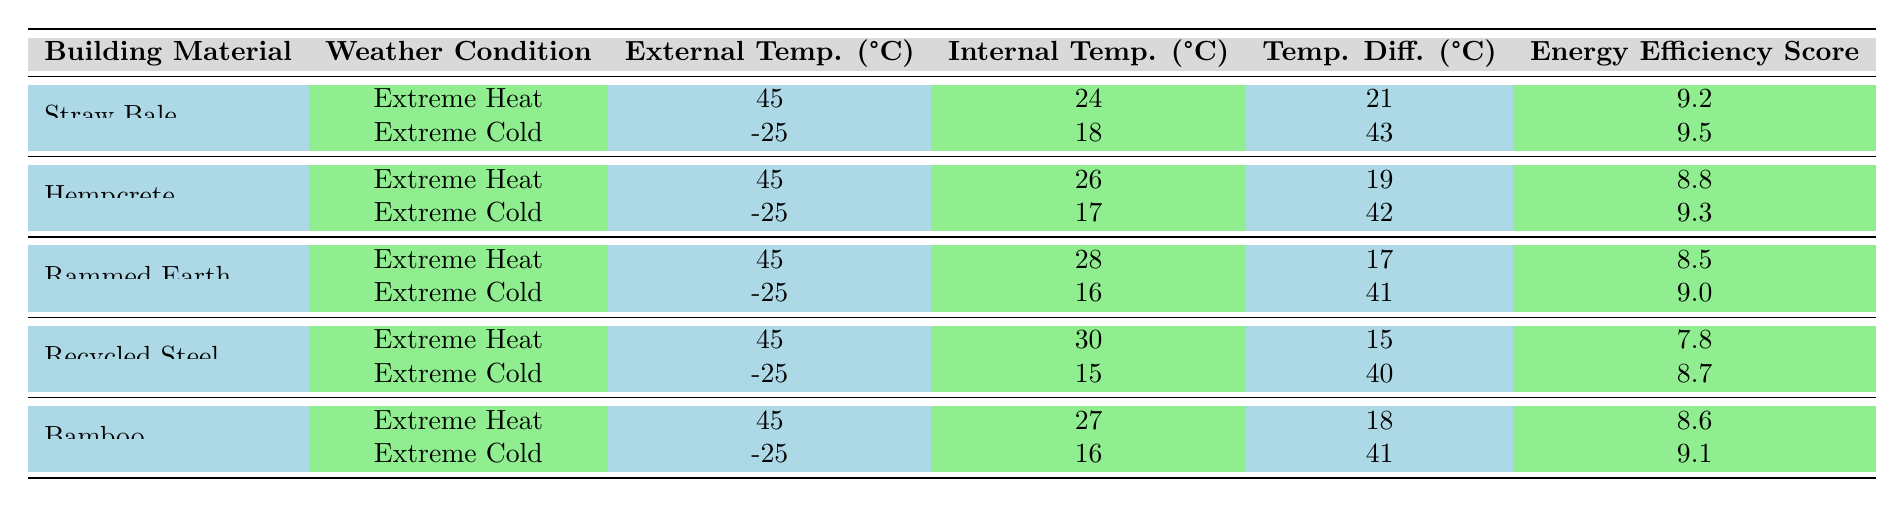What is the Energy Efficiency Score for Straw Bale in Extreme Heat? The table lists the Energy Efficiency Score for Straw Bale under Extreme Heat as 9.2.
Answer: 9.2 What is the Temperature Difference for Hempcrete in Extreme Cold? According to the table, the Temperature Difference for Hempcrete in Extreme Cold is 42°C.
Answer: 42 Which building material has the highest Energy Efficiency Score during Extreme Cold? In the table, Straw Bale has the highest Energy Efficiency Score of 9.5 in Extreme Cold.
Answer: Straw Bale What is the average Temperature Difference for Bamboo in both weather conditions? To calculate the average, add the Temperature Differences for Bamboo: (41 + 18) = 59, then divide by 2: 59 / 2 = 29.5.
Answer: 29.5 Is the Internal Temperature for Recycled Steel higher in Extreme Heat or Extreme Cold? The Internal Temperature for Recycled Steel in Extreme Heat is 30°C, while in Extreme Cold it is 15°C; therefore, it is higher in Extreme Heat.
Answer: Yes Which material maintains the highest Internal Temperature in Extreme Heat? The table shows that Recycled Steel maintains the highest Internal Temperature of 30°C in Extreme Heat.
Answer: Recycled Steel What is the total Temperature Difference for Hempcrete across both weather conditions? The total Temperature Difference for Hempcrete is (19 + 42) = 61°C.
Answer: 61 Is the Energy Efficiency Score for Rammed Earth lower in Extreme Heat compared to Bamboo in the same condition? Rammed Earth has an Energy Efficiency Score of 8.5 in Extreme Heat, while Bamboo has 8.6; thus, Rammed Earth's score is lower.
Answer: Yes What is the temperature difference between the Internal and External Temperature for Recycled Steel in Extreme Cold? For Recycled Steel in Extreme Cold, the External Temperature is -25°C and Internal is 15°C. The Temperature Difference is 40°C (15 - (-25) = 40).
Answer: 40 What is the percentage increase in Energy Efficiency Score for Hempcrete from Extreme Heat to Extreme Cold? The scores change from 8.8 in Extreme Heat to 9.3 in Extreme Cold, indicating an increase of (9.3 - 8.8) = 0.5. To find the percentage increase, use: (0.5 / 8.8) * 100 = 5.68%.
Answer: 5.68% 